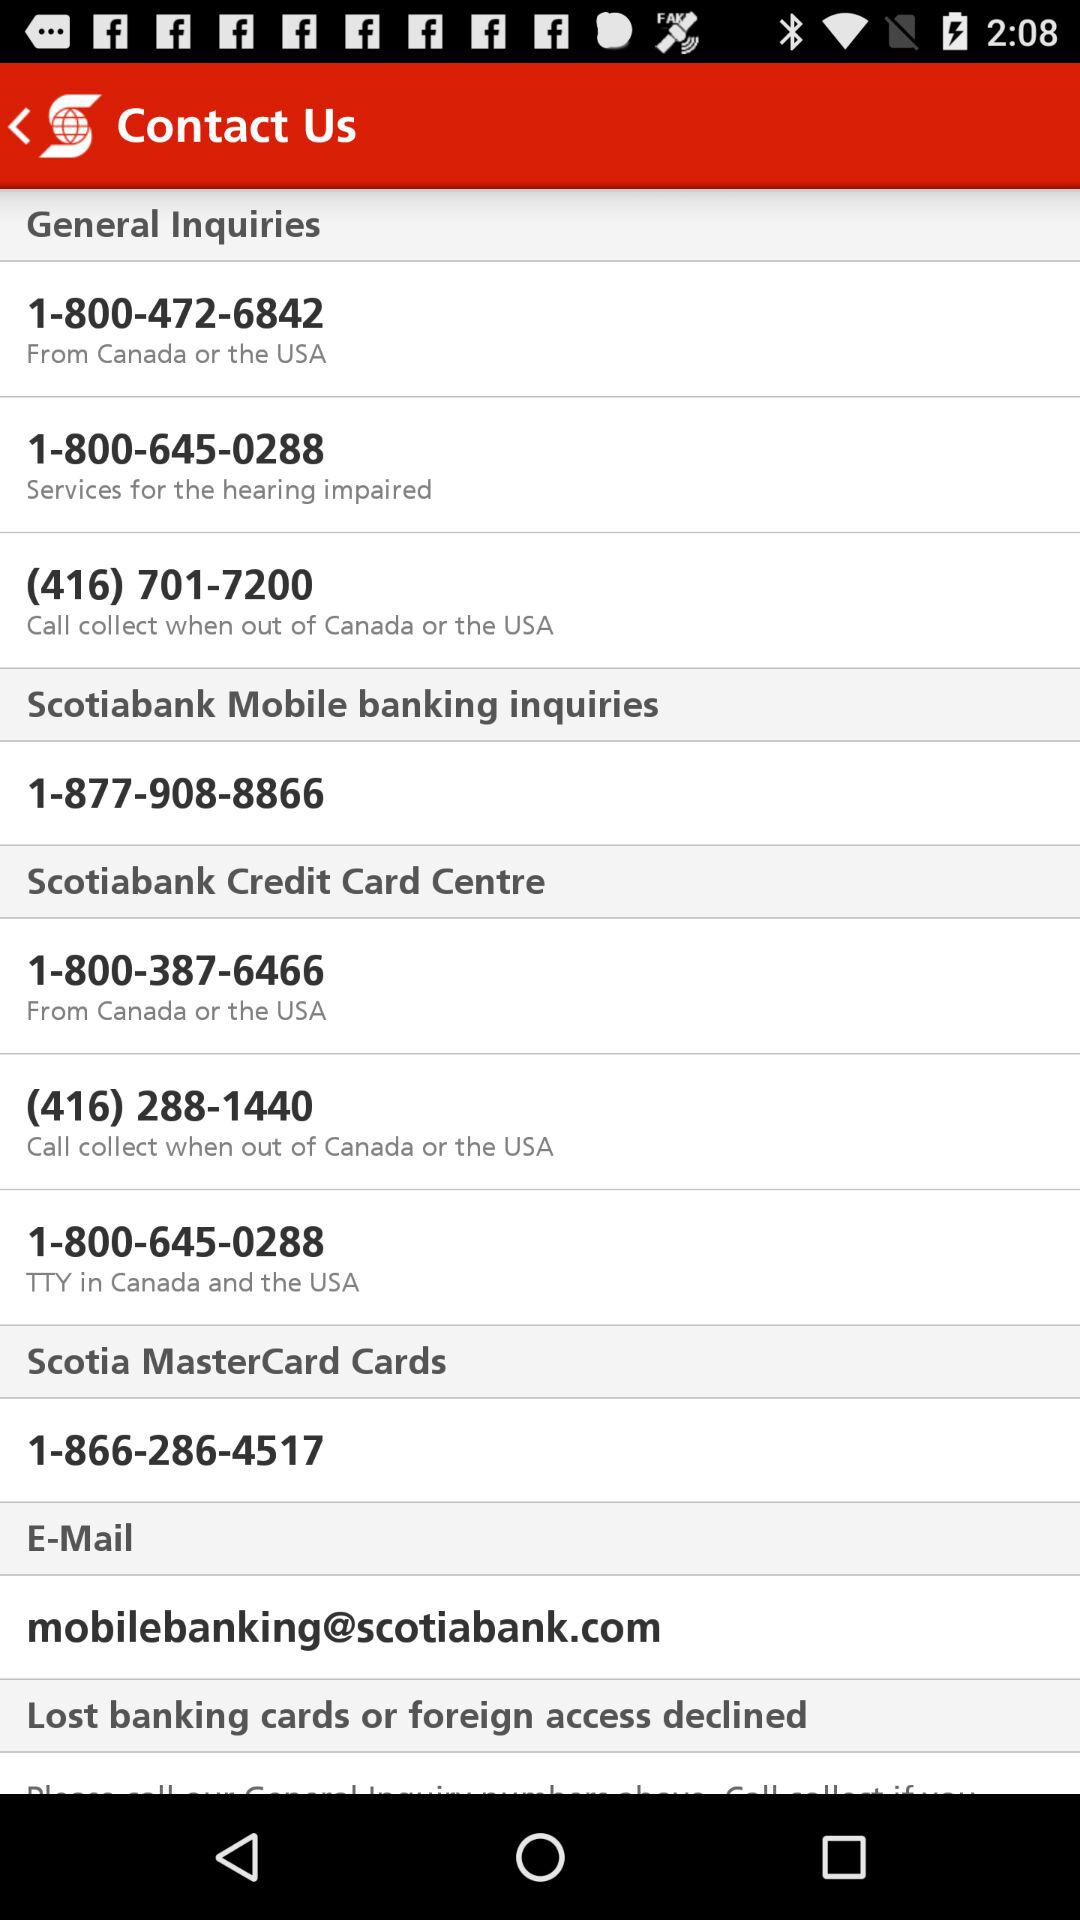Where should the call be made for "Scotia MasterCard Cards"? The call should be made to 1-866-286-4517 for "Scotia MasterCard Cards". 